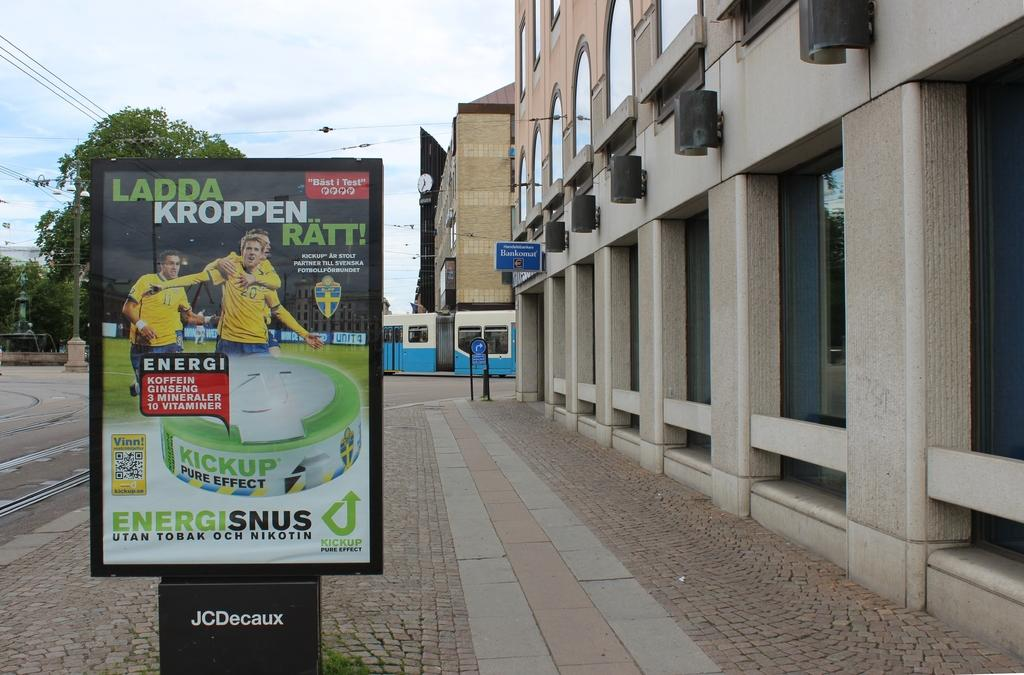<image>
Present a compact description of the photo's key features. A sign posted on the sidewalk outside of a building advertises Kickup for energy. 